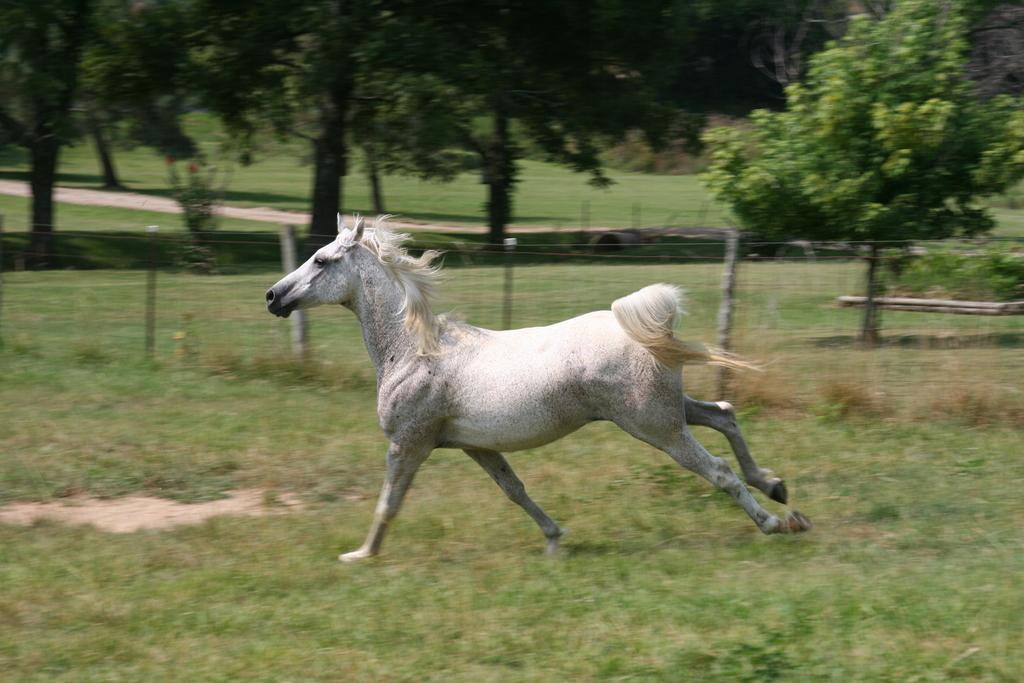What is the main subject in the foreground of the picture? There is a white horse in the foreground of the picture. What is the horse doing in the image? The horse is running on green grass. What type of fencing can be seen in the image? There is metal wire fencing in the image. What can be seen in the background of the image? There are trees in the background of the image. What type of cakes are being served in space in the image? There is no reference to cakes or space in the image; it features a white horse running on green grass with metal wire fencing and trees in the background. 